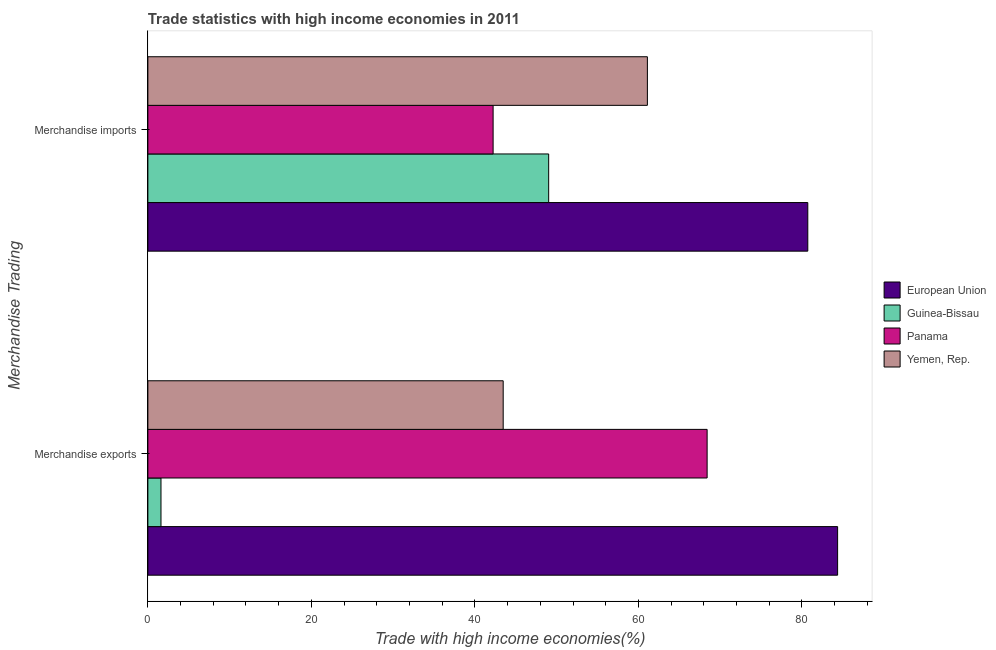How many different coloured bars are there?
Your answer should be compact. 4. Are the number of bars per tick equal to the number of legend labels?
Your answer should be compact. Yes. Are the number of bars on each tick of the Y-axis equal?
Make the answer very short. Yes. What is the label of the 2nd group of bars from the top?
Give a very brief answer. Merchandise exports. What is the merchandise imports in Guinea-Bissau?
Provide a succinct answer. 49.02. Across all countries, what is the maximum merchandise exports?
Your answer should be very brief. 84.37. Across all countries, what is the minimum merchandise exports?
Offer a very short reply. 1.6. In which country was the merchandise imports maximum?
Your answer should be very brief. European Union. In which country was the merchandise imports minimum?
Give a very brief answer. Panama. What is the total merchandise imports in the graph?
Your response must be concise. 233.07. What is the difference between the merchandise exports in Panama and that in Yemen, Rep.?
Give a very brief answer. 24.94. What is the difference between the merchandise imports in Yemen, Rep. and the merchandise exports in Panama?
Give a very brief answer. -7.31. What is the average merchandise imports per country?
Make the answer very short. 58.27. What is the difference between the merchandise imports and merchandise exports in European Union?
Ensure brevity in your answer.  -3.65. In how many countries, is the merchandise exports greater than 12 %?
Your response must be concise. 3. What is the ratio of the merchandise exports in Guinea-Bissau to that in European Union?
Offer a terse response. 0.02. Is the merchandise imports in Guinea-Bissau less than that in European Union?
Provide a succinct answer. Yes. In how many countries, is the merchandise exports greater than the average merchandise exports taken over all countries?
Keep it short and to the point. 2. What does the 3rd bar from the top in Merchandise imports represents?
Provide a short and direct response. Guinea-Bissau. What does the 1st bar from the bottom in Merchandise exports represents?
Offer a terse response. European Union. How many bars are there?
Ensure brevity in your answer.  8. How many countries are there in the graph?
Provide a short and direct response. 4. What is the difference between two consecutive major ticks on the X-axis?
Provide a short and direct response. 20. Does the graph contain grids?
Provide a succinct answer. No. What is the title of the graph?
Keep it short and to the point. Trade statistics with high income economies in 2011. What is the label or title of the X-axis?
Your answer should be compact. Trade with high income economies(%). What is the label or title of the Y-axis?
Your answer should be very brief. Merchandise Trading. What is the Trade with high income economies(%) in European Union in Merchandise exports?
Make the answer very short. 84.37. What is the Trade with high income economies(%) in Guinea-Bissau in Merchandise exports?
Ensure brevity in your answer.  1.6. What is the Trade with high income economies(%) in Panama in Merchandise exports?
Your answer should be very brief. 68.4. What is the Trade with high income economies(%) of Yemen, Rep. in Merchandise exports?
Your answer should be compact. 43.46. What is the Trade with high income economies(%) of European Union in Merchandise imports?
Your answer should be very brief. 80.72. What is the Trade with high income economies(%) of Guinea-Bissau in Merchandise imports?
Your answer should be compact. 49.02. What is the Trade with high income economies(%) of Panama in Merchandise imports?
Offer a terse response. 42.23. What is the Trade with high income economies(%) of Yemen, Rep. in Merchandise imports?
Your response must be concise. 61.1. Across all Merchandise Trading, what is the maximum Trade with high income economies(%) in European Union?
Offer a very short reply. 84.37. Across all Merchandise Trading, what is the maximum Trade with high income economies(%) in Guinea-Bissau?
Give a very brief answer. 49.02. Across all Merchandise Trading, what is the maximum Trade with high income economies(%) in Panama?
Your answer should be very brief. 68.4. Across all Merchandise Trading, what is the maximum Trade with high income economies(%) in Yemen, Rep.?
Provide a succinct answer. 61.1. Across all Merchandise Trading, what is the minimum Trade with high income economies(%) of European Union?
Your response must be concise. 80.72. Across all Merchandise Trading, what is the minimum Trade with high income economies(%) in Guinea-Bissau?
Give a very brief answer. 1.6. Across all Merchandise Trading, what is the minimum Trade with high income economies(%) in Panama?
Make the answer very short. 42.23. Across all Merchandise Trading, what is the minimum Trade with high income economies(%) in Yemen, Rep.?
Your answer should be compact. 43.46. What is the total Trade with high income economies(%) in European Union in the graph?
Your answer should be compact. 165.08. What is the total Trade with high income economies(%) in Guinea-Bissau in the graph?
Give a very brief answer. 50.63. What is the total Trade with high income economies(%) of Panama in the graph?
Offer a terse response. 110.63. What is the total Trade with high income economies(%) in Yemen, Rep. in the graph?
Your answer should be compact. 104.56. What is the difference between the Trade with high income economies(%) in European Union in Merchandise exports and that in Merchandise imports?
Your response must be concise. 3.65. What is the difference between the Trade with high income economies(%) of Guinea-Bissau in Merchandise exports and that in Merchandise imports?
Offer a very short reply. -47.42. What is the difference between the Trade with high income economies(%) in Panama in Merchandise exports and that in Merchandise imports?
Provide a short and direct response. 26.18. What is the difference between the Trade with high income economies(%) of Yemen, Rep. in Merchandise exports and that in Merchandise imports?
Your answer should be compact. -17.64. What is the difference between the Trade with high income economies(%) of European Union in Merchandise exports and the Trade with high income economies(%) of Guinea-Bissau in Merchandise imports?
Provide a succinct answer. 35.34. What is the difference between the Trade with high income economies(%) in European Union in Merchandise exports and the Trade with high income economies(%) in Panama in Merchandise imports?
Offer a very short reply. 42.14. What is the difference between the Trade with high income economies(%) of European Union in Merchandise exports and the Trade with high income economies(%) of Yemen, Rep. in Merchandise imports?
Your response must be concise. 23.27. What is the difference between the Trade with high income economies(%) of Guinea-Bissau in Merchandise exports and the Trade with high income economies(%) of Panama in Merchandise imports?
Give a very brief answer. -40.62. What is the difference between the Trade with high income economies(%) in Guinea-Bissau in Merchandise exports and the Trade with high income economies(%) in Yemen, Rep. in Merchandise imports?
Ensure brevity in your answer.  -59.49. What is the difference between the Trade with high income economies(%) in Panama in Merchandise exports and the Trade with high income economies(%) in Yemen, Rep. in Merchandise imports?
Your answer should be compact. 7.31. What is the average Trade with high income economies(%) in European Union per Merchandise Trading?
Make the answer very short. 82.54. What is the average Trade with high income economies(%) in Guinea-Bissau per Merchandise Trading?
Provide a succinct answer. 25.31. What is the average Trade with high income economies(%) in Panama per Merchandise Trading?
Offer a terse response. 55.32. What is the average Trade with high income economies(%) of Yemen, Rep. per Merchandise Trading?
Offer a terse response. 52.28. What is the difference between the Trade with high income economies(%) of European Union and Trade with high income economies(%) of Guinea-Bissau in Merchandise exports?
Provide a short and direct response. 82.76. What is the difference between the Trade with high income economies(%) in European Union and Trade with high income economies(%) in Panama in Merchandise exports?
Your answer should be very brief. 15.96. What is the difference between the Trade with high income economies(%) in European Union and Trade with high income economies(%) in Yemen, Rep. in Merchandise exports?
Make the answer very short. 40.9. What is the difference between the Trade with high income economies(%) of Guinea-Bissau and Trade with high income economies(%) of Panama in Merchandise exports?
Your answer should be compact. -66.8. What is the difference between the Trade with high income economies(%) of Guinea-Bissau and Trade with high income economies(%) of Yemen, Rep. in Merchandise exports?
Make the answer very short. -41.86. What is the difference between the Trade with high income economies(%) in Panama and Trade with high income economies(%) in Yemen, Rep. in Merchandise exports?
Offer a very short reply. 24.94. What is the difference between the Trade with high income economies(%) in European Union and Trade with high income economies(%) in Guinea-Bissau in Merchandise imports?
Make the answer very short. 31.69. What is the difference between the Trade with high income economies(%) in European Union and Trade with high income economies(%) in Panama in Merchandise imports?
Make the answer very short. 38.49. What is the difference between the Trade with high income economies(%) in European Union and Trade with high income economies(%) in Yemen, Rep. in Merchandise imports?
Make the answer very short. 19.62. What is the difference between the Trade with high income economies(%) in Guinea-Bissau and Trade with high income economies(%) in Panama in Merchandise imports?
Your response must be concise. 6.8. What is the difference between the Trade with high income economies(%) of Guinea-Bissau and Trade with high income economies(%) of Yemen, Rep. in Merchandise imports?
Provide a short and direct response. -12.07. What is the difference between the Trade with high income economies(%) in Panama and Trade with high income economies(%) in Yemen, Rep. in Merchandise imports?
Make the answer very short. -18.87. What is the ratio of the Trade with high income economies(%) of European Union in Merchandise exports to that in Merchandise imports?
Offer a terse response. 1.05. What is the ratio of the Trade with high income economies(%) in Guinea-Bissau in Merchandise exports to that in Merchandise imports?
Your response must be concise. 0.03. What is the ratio of the Trade with high income economies(%) of Panama in Merchandise exports to that in Merchandise imports?
Your answer should be compact. 1.62. What is the ratio of the Trade with high income economies(%) of Yemen, Rep. in Merchandise exports to that in Merchandise imports?
Provide a succinct answer. 0.71. What is the difference between the highest and the second highest Trade with high income economies(%) of European Union?
Your response must be concise. 3.65. What is the difference between the highest and the second highest Trade with high income economies(%) of Guinea-Bissau?
Give a very brief answer. 47.42. What is the difference between the highest and the second highest Trade with high income economies(%) in Panama?
Keep it short and to the point. 26.18. What is the difference between the highest and the second highest Trade with high income economies(%) in Yemen, Rep.?
Make the answer very short. 17.64. What is the difference between the highest and the lowest Trade with high income economies(%) of European Union?
Offer a very short reply. 3.65. What is the difference between the highest and the lowest Trade with high income economies(%) in Guinea-Bissau?
Give a very brief answer. 47.42. What is the difference between the highest and the lowest Trade with high income economies(%) of Panama?
Give a very brief answer. 26.18. What is the difference between the highest and the lowest Trade with high income economies(%) of Yemen, Rep.?
Offer a very short reply. 17.64. 